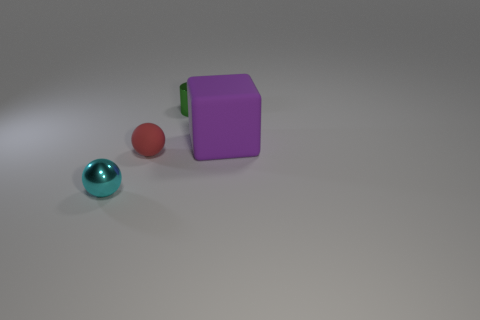Add 3 big red metallic things. How many objects exist? 7 Subtract all cylinders. How many objects are left? 3 Add 3 small cyan metal objects. How many small cyan metal objects are left? 4 Add 1 small cyan matte spheres. How many small cyan matte spheres exist? 1 Subtract 0 gray cylinders. How many objects are left? 4 Subtract all purple blocks. Subtract all big metal cylinders. How many objects are left? 3 